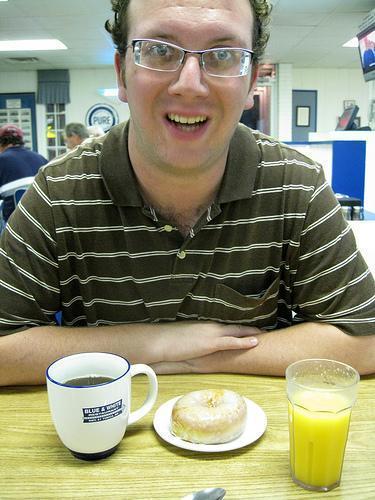How many people's faces are visible?
Give a very brief answer. 2. 